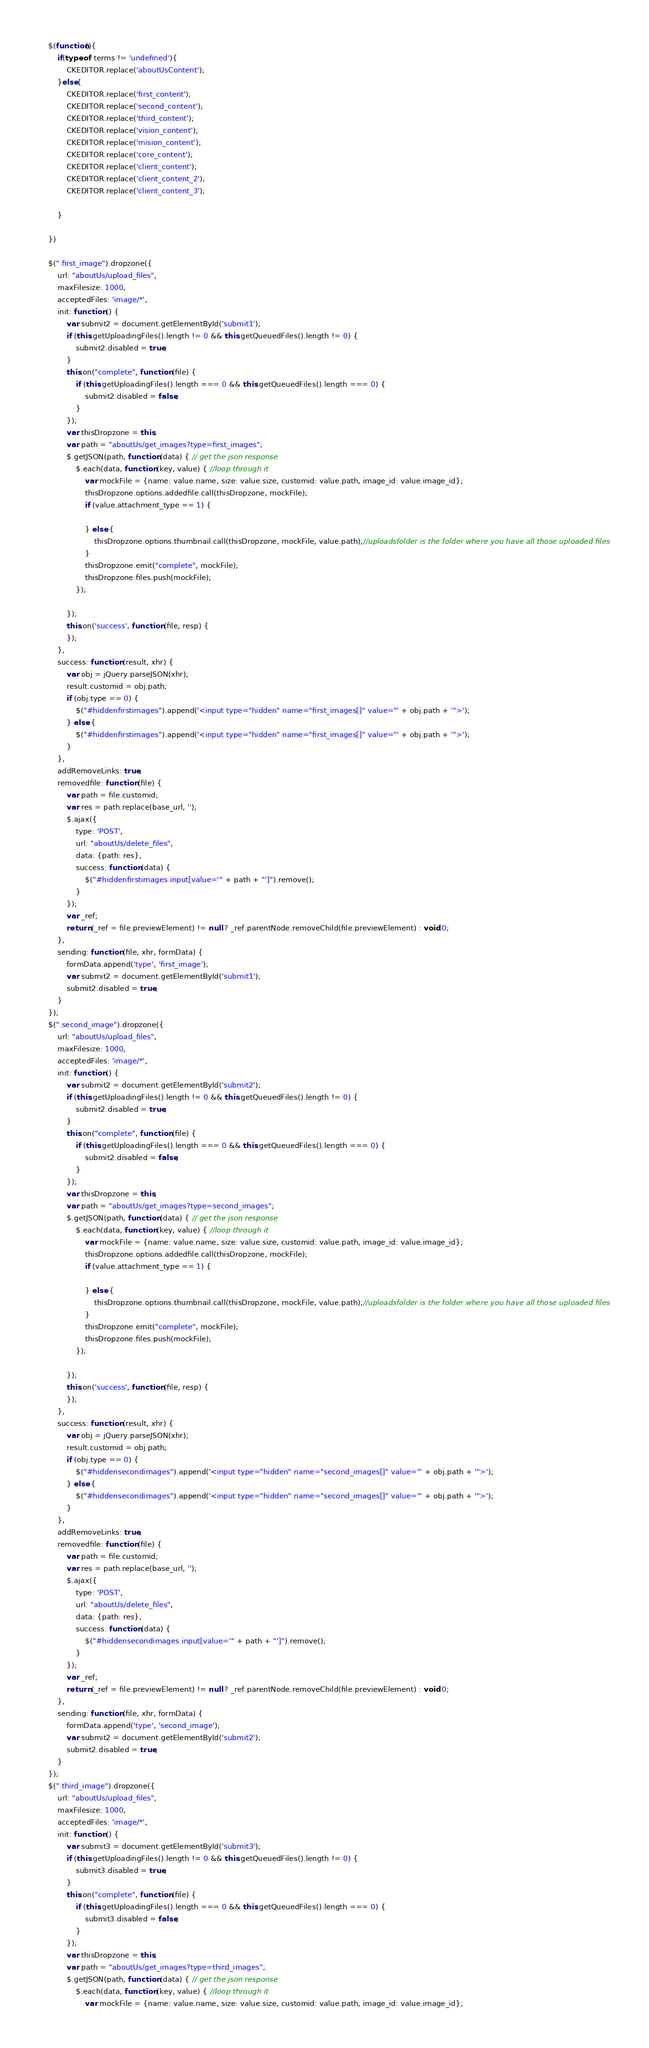Convert code to text. <code><loc_0><loc_0><loc_500><loc_500><_JavaScript_>    $(function(){
        if(typeof  terms != 'undefined'){
            CKEDITOR.replace('aboutUsContent');
        }else{
            CKEDITOR.replace('first_content');
            CKEDITOR.replace('second_content');
            CKEDITOR.replace('third_content');             
            CKEDITOR.replace('vision_content');
            CKEDITOR.replace('mision_content');
            CKEDITOR.replace('core_content');
            CKEDITOR.replace('client_content');
            CKEDITOR.replace('client_content_2');
            CKEDITOR.replace('client_content_3'); 

        }

    })

    $(".first_image").dropzone({
        url: "aboutUs/upload_files",
        maxFilesize: 1000,
        acceptedFiles: 'image/*',
        init: function () {
            var submit2 = document.getElementById('submit1');
            if (this.getUploadingFiles().length != 0 && this.getQueuedFiles().length != 0) {
                submit2.disabled = true;
            }
            this.on("complete", function (file) {
                if (this.getUploadingFiles().length === 0 && this.getQueuedFiles().length === 0) {
                    submit2.disabled = false;
                }
            });
            var thisDropzone = this;
            var path = "aboutUs/get_images?type=first_images";
            $.getJSON(path, function (data) { // get the json response
                $.each(data, function (key, value) { //loop through it                    
                    var mockFile = {name: value.name, size: value.size, customid: value.path, image_id: value.image_id};
                    thisDropzone.options.addedfile.call(thisDropzone, mockFile);
                    if (value.attachment_type == 1) {

                    } else {
                        thisDropzone.options.thumbnail.call(thisDropzone, mockFile, value.path);//uploadsfolder is the folder where you have all those uploaded files
                    }
                    thisDropzone.emit("complete", mockFile);
                    thisDropzone.files.push(mockFile);
                });

            });
            this.on('success', function (file, resp) {
            });
        },
        success: function (result, xhr) {
            var obj = jQuery.parseJSON(xhr);
            result.customid = obj.path;
            if (obj.type == 0) {
                $("#hiddenfirstimages").append('<input type="hidden" name="first_images[]" value="' + obj.path + '">');
            } else {
                $("#hiddenfirstimages").append('<input type="hidden" name="first_images[]" value="' + obj.path + '">');
            }
        },
        addRemoveLinks: true,
        removedfile: function (file) {
            var path = file.customid;
            var res = path.replace(base_url, '');
            $.ajax({
                type: 'POST',
                url: "aboutUs/delete_files",
                data: {path: res},
                success: function (data) {
                    $("#hiddenfirstimages input[value='" + path + "']").remove();
                }
            });
            var _ref;
            return (_ref = file.previewElement) != null ? _ref.parentNode.removeChild(file.previewElement) : void 0;
        },
        sending: function (file, xhr, formData) {
            formData.append('type', 'first_image');
            var submit2 = document.getElementById('submit1');
            submit2.disabled = true;
        }
    });
    $(".second_image").dropzone({
        url: "aboutUs/upload_files",
        maxFilesize: 1000,
        acceptedFiles: 'image/*',
        init: function () {
            var submit2 = document.getElementById('submit2');
            if (this.getUploadingFiles().length != 0 && this.getQueuedFiles().length != 0) {
                submit2.disabled = true;
            }
            this.on("complete", function (file) {
                if (this.getUploadingFiles().length === 0 && this.getQueuedFiles().length === 0) {
                    submit2.disabled = false;
                }
            });
            var thisDropzone = this;
            var path = "aboutUs/get_images?type=second_images";
            $.getJSON(path, function (data) { // get the json response
                $.each(data, function (key, value) { //loop through it
                    var mockFile = {name: value.name, size: value.size, customid: value.path, image_id: value.image_id};
                    thisDropzone.options.addedfile.call(thisDropzone, mockFile);
                    if (value.attachment_type == 1) {

                    } else {
                        thisDropzone.options.thumbnail.call(thisDropzone, mockFile, value.path);//uploadsfolder is the folder where you have all those uploaded files
                    }
                    thisDropzone.emit("complete", mockFile);
                    thisDropzone.files.push(mockFile);
                });

            });
            this.on('success', function (file, resp) {
            });
        },
        success: function (result, xhr) {
            var obj = jQuery.parseJSON(xhr);
            result.customid = obj.path;
            if (obj.type == 0) {
                $("#hiddensecondimages").append('<input type="hidden" name="second_images[]" value="' + obj.path + '">');
            } else {
                $("#hiddensecondimages").append('<input type="hidden" name="second_images[]" value="' + obj.path + '">');
            }
        },
        addRemoveLinks: true,
        removedfile: function (file) {
            var path = file.customid;
            var res = path.replace(base_url, '');
            $.ajax({
                type: 'POST',
                url: "aboutUs/delete_files",
                data: {path: res},
                success: function (data) {
                    $("#hiddensecondimages input[value='" + path + "']").remove();
                }
            });
            var _ref;
            return (_ref = file.previewElement) != null ? _ref.parentNode.removeChild(file.previewElement) : void 0;
        },
        sending: function (file, xhr, formData) {
            formData.append('type', 'second_image');
            var submit2 = document.getElementById('submit2');
            submit2.disabled = true;
        }
    });
    $(".third_image").dropzone({
        url: "aboutUs/upload_files",
        maxFilesize: 1000,
        acceptedFiles: 'image/*',
        init: function () {
            var submit3 = document.getElementById('submit3');
            if (this.getUploadingFiles().length != 0 && this.getQueuedFiles().length != 0) {
                submit3.disabled = true;
            }
            this.on("complete", function (file) {
                if (this.getUploadingFiles().length === 0 && this.getQueuedFiles().length === 0) {
                    submit3.disabled = false;
                }
            });
            var thisDropzone = this;
            var path = "aboutUs/get_images?type=third_images";
            $.getJSON(path, function (data) { // get the json response
                $.each(data, function (key, value) { //loop through it
                    var mockFile = {name: value.name, size: value.size, customid: value.path, image_id: value.image_id};</code> 